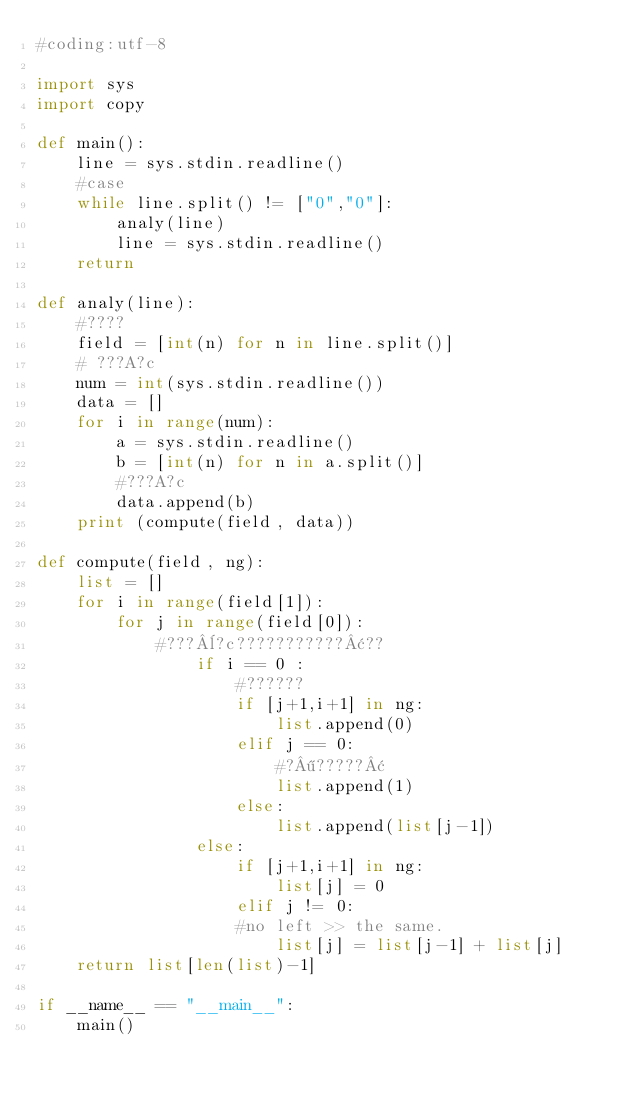Convert code to text. <code><loc_0><loc_0><loc_500><loc_500><_Python_>#coding:utf-8
  
import sys
import copy
  
def main():
    line = sys.stdin.readline()
    #case
    while line.split() != ["0","0"]:
        analy(line)
        line = sys.stdin.readline()
    return
  
def analy(line):
    #????
    field = [int(n) for n in line.split()]
    # ???A?c
    num = int(sys.stdin.readline())
    data = []
    for i in range(num):
        a = sys.stdin.readline()
        b = [int(n) for n in a.split()]
        #???A?c
        data.append(b)
    print (compute(field, data))
  
def compute(field, ng):
    list = []
    for i in range(field[1]):
        for j in range(field[0]):
            #???¨?c???????????¢??
                if i == 0 :
                    #??????
                    if [j+1,i+1] in ng:
                        list.append(0)
                    elif j == 0:
                        #?¶?????¢
                        list.append(1)
                    else:
                        list.append(list[j-1])
                else:
                    if [j+1,i+1] in ng:
                        list[j] = 0
                    elif j != 0:
                    #no left >> the same.
                        list[j] = list[j-1] + list[j]
    return list[len(list)-1]
  
if __name__ == "__main__":
    main()</code> 